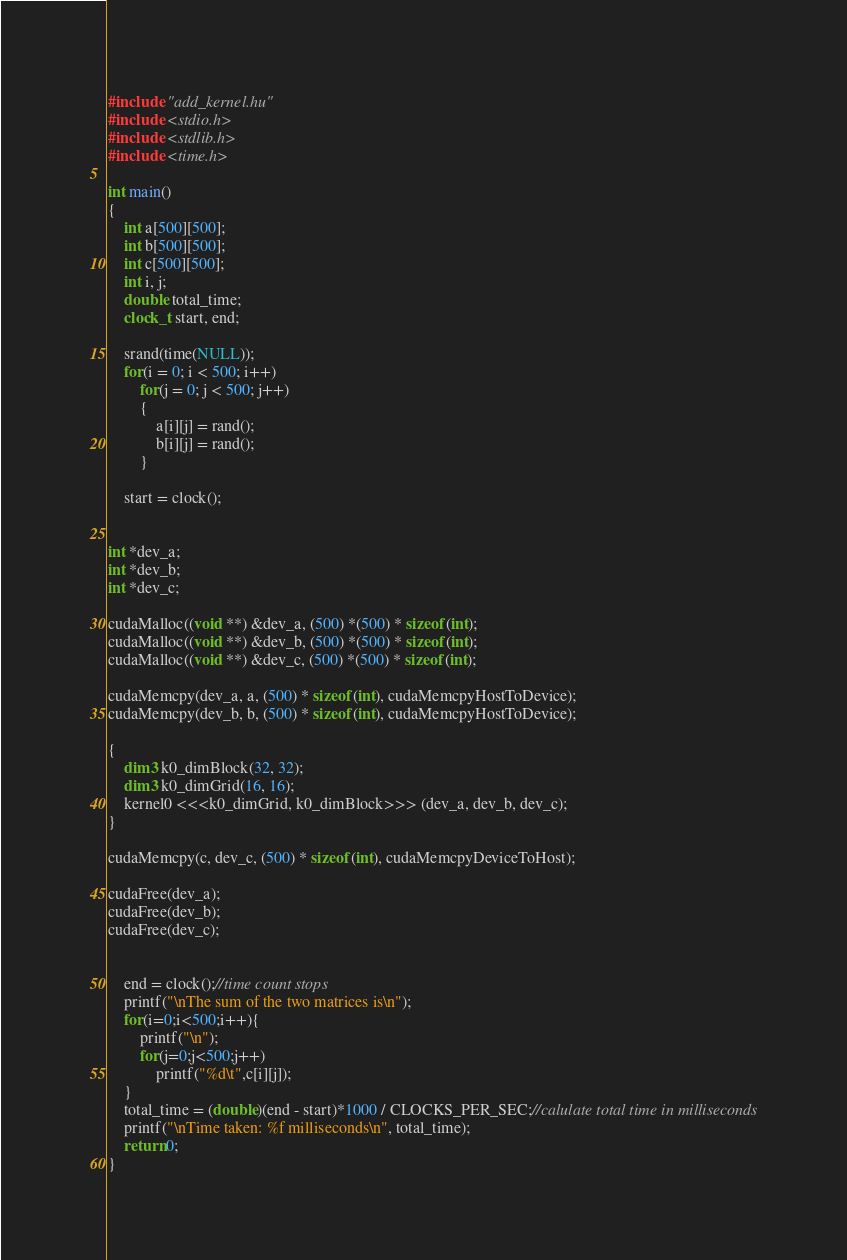<code> <loc_0><loc_0><loc_500><loc_500><_Cuda_>#include "add_kernel.hu"
#include <stdio.h>
#include <stdlib.h>
#include <time.h>

int main()
{
    int a[500][500];
    int b[500][500];
    int c[500][500];
    int i, j;
    double total_time;
    clock_t start, end;
  
    srand(time(NULL));
    for(i = 0; i < 500; i++)
        for(j = 0; j < 500; j++)
        {
            a[i][j] = rand();
            b[i][j] = rand();
        }
  
    start = clock();

    
int *dev_a;
int *dev_b;
int *dev_c;

cudaMalloc((void **) &dev_a, (500) *(500) * sizeof(int);
cudaMalloc((void **) &dev_b, (500) *(500) * sizeof(int);
cudaMalloc((void **) &dev_c, (500) *(500) * sizeof(int);

cudaMemcpy(dev_a, a, (500) * sizeof(int), cudaMemcpyHostToDevice);
cudaMemcpy(dev_b, b, (500) * sizeof(int), cudaMemcpyHostToDevice);

{
	dim3 k0_dimBlock(32, 32);
	dim3 k0_dimGrid(16, 16);
	kernel0 <<<k0_dimGrid, k0_dimBlock>>> (dev_a, dev_b, dev_c);
}

cudaMemcpy(c, dev_c, (500) * sizeof(int), cudaMemcpyDeviceToHost);

cudaFree(dev_a);
cudaFree(dev_b);
cudaFree(dev_c);

    
    end = clock();//time count stops 
    printf("\nThe sum of the two matrices is\n");
    for(i=0;i<500;i++){
        printf("\n");
        for(j=0;j<500;j++)
            printf("%d\t",c[i][j]);
    }
    total_time = (double)(end - start)*1000 / CLOCKS_PER_SEC;//calulate total time in milliseconds
    printf("\nTime taken: %f milliseconds\n", total_time);
    return 0;
}
</code> 